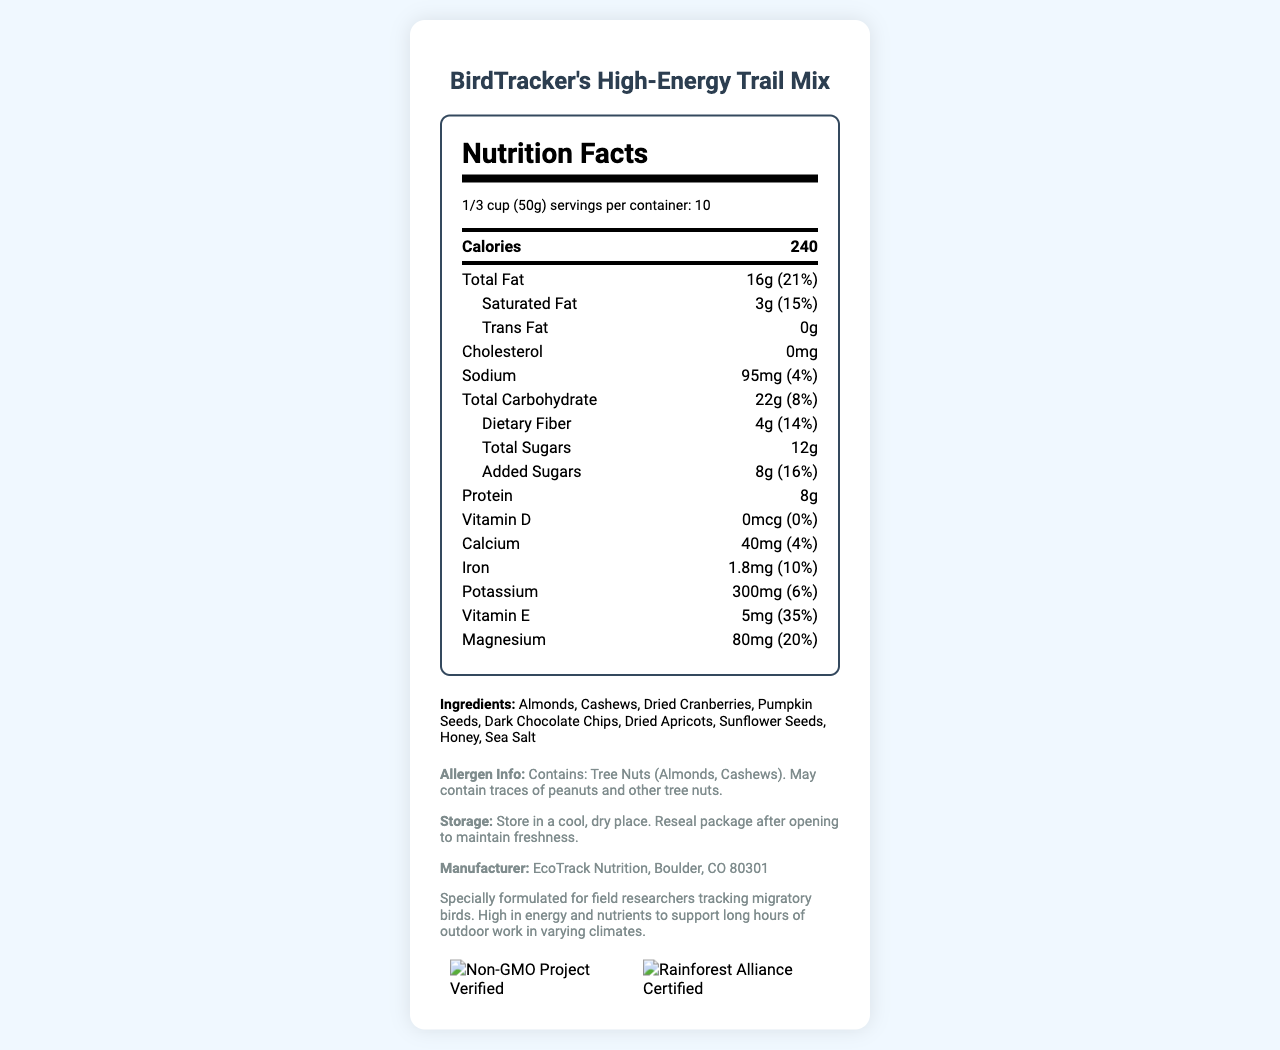what is the serving size of BirdTracker's High-Energy Trail Mix? The serving size is listed as 1/3 cup (50g) in the label.
Answer: 1/3 cup (50g) how many servings per container are provided? The document states that there are 10 servings per container.
Answer: 10 what is the main source of sugar in the trail mix as per the ingredients list? The primary sources of sugar listed in the ingredients are Dried Cranberries and Honey.
Answer: Dried Cranberries, Honey what percentage of the daily value for Total Fat does one serving provide? The label indicates that one serving of the trail mix provides 16g of Total Fat, which is 21% of the daily value.
Answer: 21% how much Dietary Fiber is in one serving? According to the nutrition label, one serving contains 4g of Dietary Fiber.
Answer: 4g what is the total amount of protein per serving? The nutrition label states that each serving contains 8g of Protein.
Answer: 8g which ingredient is not a nut but is included in the trail mix? A. Almonds B. Cashews C. Pumpkin Seeds D. Honey According to the ingredients list, Pumpkin Seeds are not nuts but are part of the trail mix.
Answer: C what is the total amount of calories in the entire container? A. 2400 B. 240 C. 1000 D. 1200 With 240 calories per serving and 10 servings in total, the entire container contains 2400 calories.
Answer: A is the product free from Trans Fat? The label confirms that there are 0g of Trans Fat in the product.
Answer: Yes what is the main purpose of this trail mix as indicated in the additional information? The additional information section describes that this trail mix is specially formulated for field researchers tracking migratory birds and provides high energy and nutrients for outdoor work.
Answer: Specially formulated for field researchers tracking migratory birds. High in energy and nutrients to support long hours of outdoor work in varying climates. does this product contain peanuts? The allergen information indicates that it may contain traces of peanuts, but it does not confirm whether peanuts are an ingredient.
Answer: Cannot be determined describe the entire document The document offers an extensive overview of the BirdTracker's High-Energy Trail Mix, covering its nutritional content, ingredients, specific intended use, and certifications. This information is designed to cater to the needs of field researchers who require high-energy foods for rigorous work routines.
Answer: This document provides the nutrition facts and other relevant information for BirdTracker's High-Energy Trail Mix. It includes details on serving size, calories, macronutrients, vitamins and minerals, ingredients, allergen information, storage instructions, manufacturer details, and certifications. The trail mix is specially formulated for field researchers tracking migratory birds to provide them with high energy and nutrient levels. 